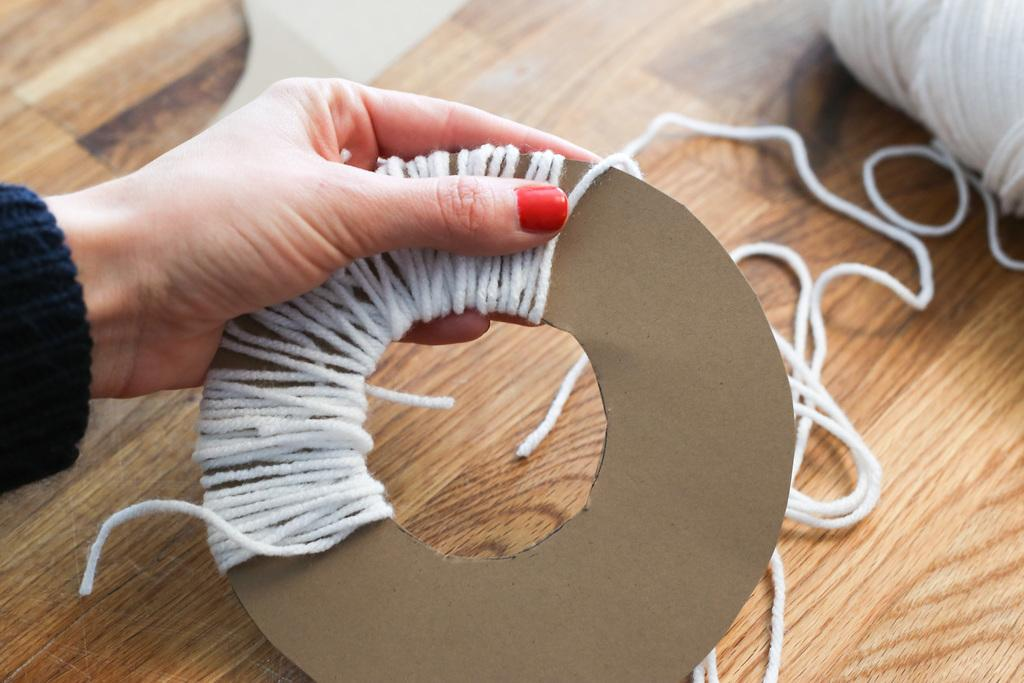What is being held by the person's hand in the image? The hand is holding a cardboard and thread bundle. Where is the cardboard and thread bundle located? The bundle is on a table. Can you describe the setting of the image? The image is taken inside a room. How many crayons are on the table next to the person's hand? There is no mention of crayons in the image, so we cannot determine the number of crayons present. 